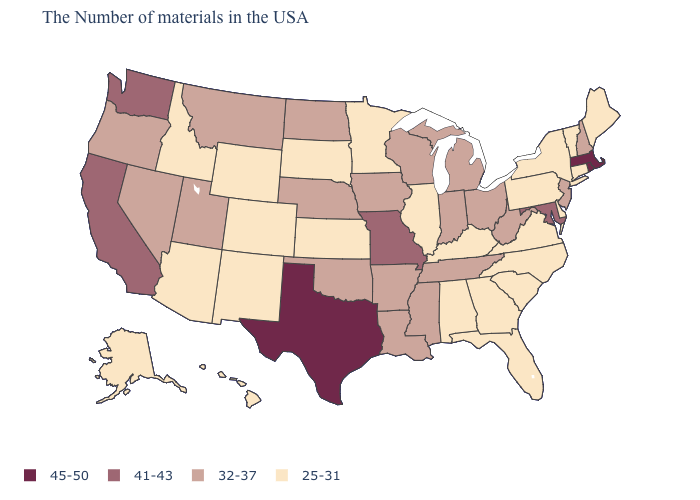Does the map have missing data?
Write a very short answer. No. Among the states that border Maryland , which have the lowest value?
Short answer required. Delaware, Pennsylvania, Virginia. Name the states that have a value in the range 32-37?
Short answer required. New Hampshire, New Jersey, West Virginia, Ohio, Michigan, Indiana, Tennessee, Wisconsin, Mississippi, Louisiana, Arkansas, Iowa, Nebraska, Oklahoma, North Dakota, Utah, Montana, Nevada, Oregon. What is the value of Virginia?
Write a very short answer. 25-31. What is the value of North Carolina?
Answer briefly. 25-31. Is the legend a continuous bar?
Short answer required. No. What is the value of South Carolina?
Keep it brief. 25-31. What is the lowest value in the West?
Short answer required. 25-31. Does the map have missing data?
Answer briefly. No. Name the states that have a value in the range 32-37?
Short answer required. New Hampshire, New Jersey, West Virginia, Ohio, Michigan, Indiana, Tennessee, Wisconsin, Mississippi, Louisiana, Arkansas, Iowa, Nebraska, Oklahoma, North Dakota, Utah, Montana, Nevada, Oregon. Which states have the lowest value in the USA?
Keep it brief. Maine, Vermont, Connecticut, New York, Delaware, Pennsylvania, Virginia, North Carolina, South Carolina, Florida, Georgia, Kentucky, Alabama, Illinois, Minnesota, Kansas, South Dakota, Wyoming, Colorado, New Mexico, Arizona, Idaho, Alaska, Hawaii. Among the states that border California , does Arizona have the lowest value?
Be succinct. Yes. Name the states that have a value in the range 25-31?
Give a very brief answer. Maine, Vermont, Connecticut, New York, Delaware, Pennsylvania, Virginia, North Carolina, South Carolina, Florida, Georgia, Kentucky, Alabama, Illinois, Minnesota, Kansas, South Dakota, Wyoming, Colorado, New Mexico, Arizona, Idaho, Alaska, Hawaii. Does the map have missing data?
Answer briefly. No. What is the value of Arkansas?
Answer briefly. 32-37. 